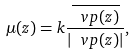Convert formula to latex. <formula><loc_0><loc_0><loc_500><loc_500>\mu ( z ) = k \frac { \overline { \ v p ( z ) } } { | \ v p ( z ) | } ,</formula> 